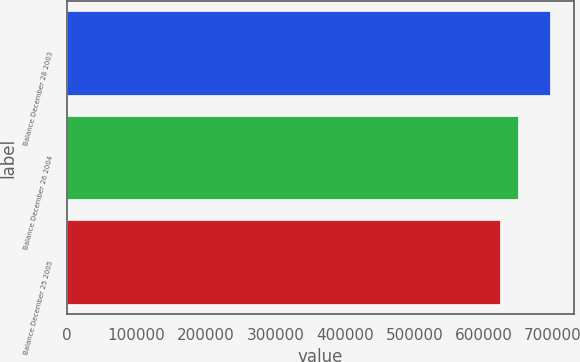<chart> <loc_0><loc_0><loc_500><loc_500><bar_chart><fcel>Balance December 28 2003<fcel>Balance December 26 2004<fcel>Balance December 25 2005<nl><fcel>694983<fcel>649367<fcel>623901<nl></chart> 